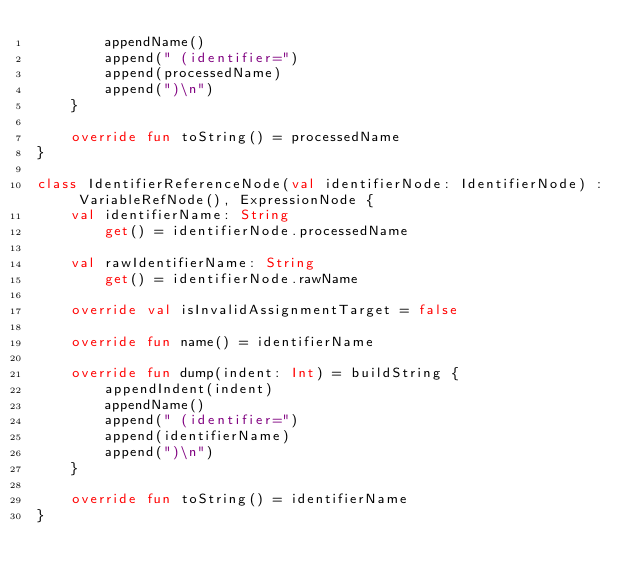Convert code to text. <code><loc_0><loc_0><loc_500><loc_500><_Kotlin_>        appendName()
        append(" (identifier=")
        append(processedName)
        append(")\n")
    }

    override fun toString() = processedName
}

class IdentifierReferenceNode(val identifierNode: IdentifierNode) : VariableRefNode(), ExpressionNode {
    val identifierName: String
        get() = identifierNode.processedName

    val rawIdentifierName: String
        get() = identifierNode.rawName

    override val isInvalidAssignmentTarget = false

    override fun name() = identifierName

    override fun dump(indent: Int) = buildString {
        appendIndent(indent)
        appendName()
        append(" (identifier=")
        append(identifierName)
        append(")\n")
    }

    override fun toString() = identifierName
}
</code> 